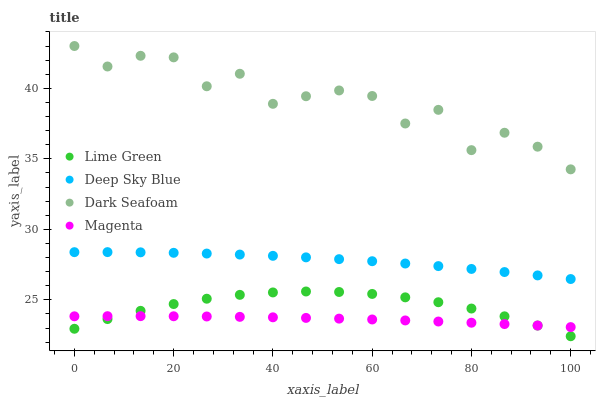Does Magenta have the minimum area under the curve?
Answer yes or no. Yes. Does Dark Seafoam have the maximum area under the curve?
Answer yes or no. Yes. Does Lime Green have the minimum area under the curve?
Answer yes or no. No. Does Lime Green have the maximum area under the curve?
Answer yes or no. No. Is Magenta the smoothest?
Answer yes or no. Yes. Is Dark Seafoam the roughest?
Answer yes or no. Yes. Is Lime Green the smoothest?
Answer yes or no. No. Is Lime Green the roughest?
Answer yes or no. No. Does Lime Green have the lowest value?
Answer yes or no. Yes. Does Magenta have the lowest value?
Answer yes or no. No. Does Dark Seafoam have the highest value?
Answer yes or no. Yes. Does Lime Green have the highest value?
Answer yes or no. No. Is Lime Green less than Deep Sky Blue?
Answer yes or no. Yes. Is Dark Seafoam greater than Magenta?
Answer yes or no. Yes. Does Magenta intersect Lime Green?
Answer yes or no. Yes. Is Magenta less than Lime Green?
Answer yes or no. No. Is Magenta greater than Lime Green?
Answer yes or no. No. Does Lime Green intersect Deep Sky Blue?
Answer yes or no. No. 